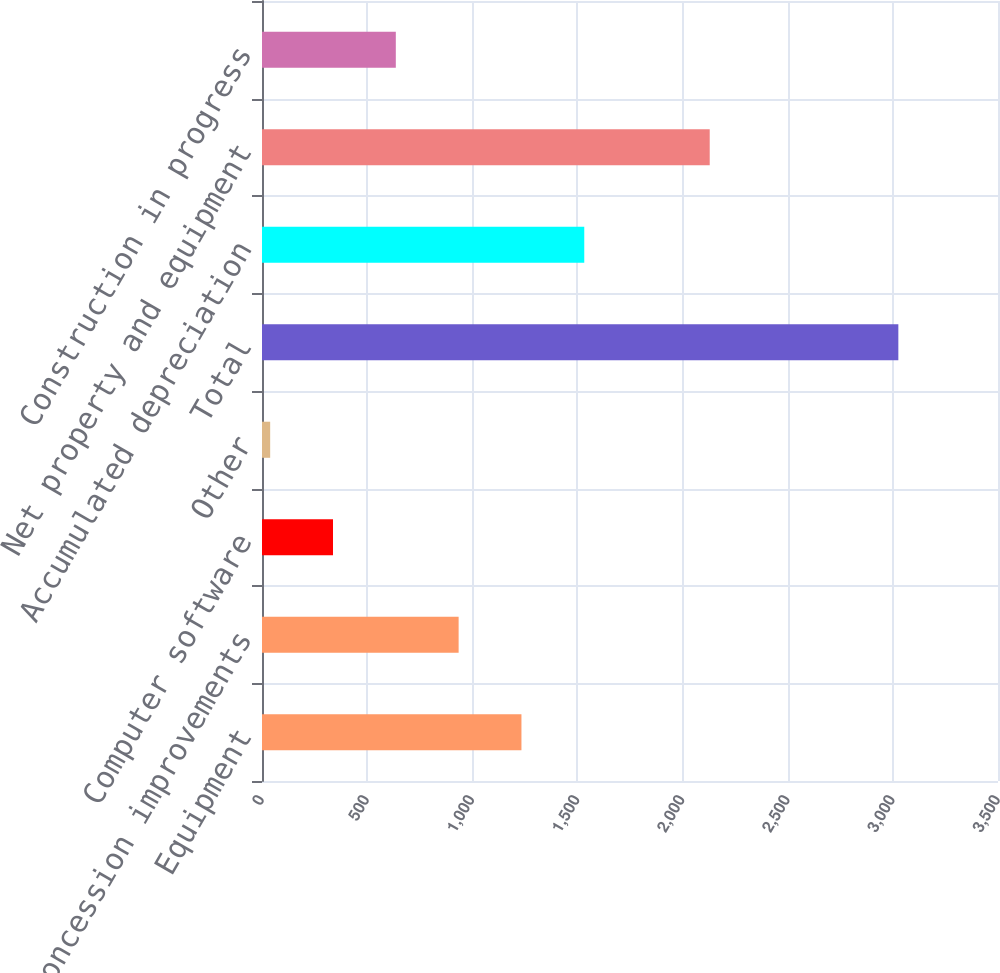<chart> <loc_0><loc_0><loc_500><loc_500><bar_chart><fcel>Equipment<fcel>Concession improvements<fcel>Computer software<fcel>Other<fcel>Total<fcel>Accumulated depreciation<fcel>Net property and equipment<fcel>Construction in progress<nl><fcel>1233.78<fcel>935.06<fcel>337.62<fcel>38.9<fcel>3026.1<fcel>1532.5<fcel>2129.1<fcel>636.34<nl></chart> 